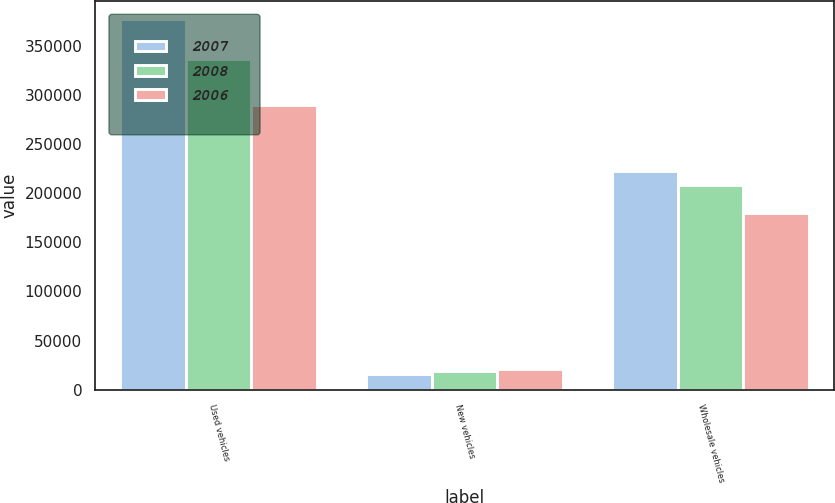Convert chart to OTSL. <chart><loc_0><loc_0><loc_500><loc_500><stacked_bar_chart><ecel><fcel>Used vehicles<fcel>New vehicles<fcel>Wholesale vehicles<nl><fcel>2007<fcel>377244<fcel>15485<fcel>222406<nl><fcel>2008<fcel>337021<fcel>18563<fcel>208959<nl><fcel>2006<fcel>289888<fcel>20901<fcel>179548<nl></chart> 